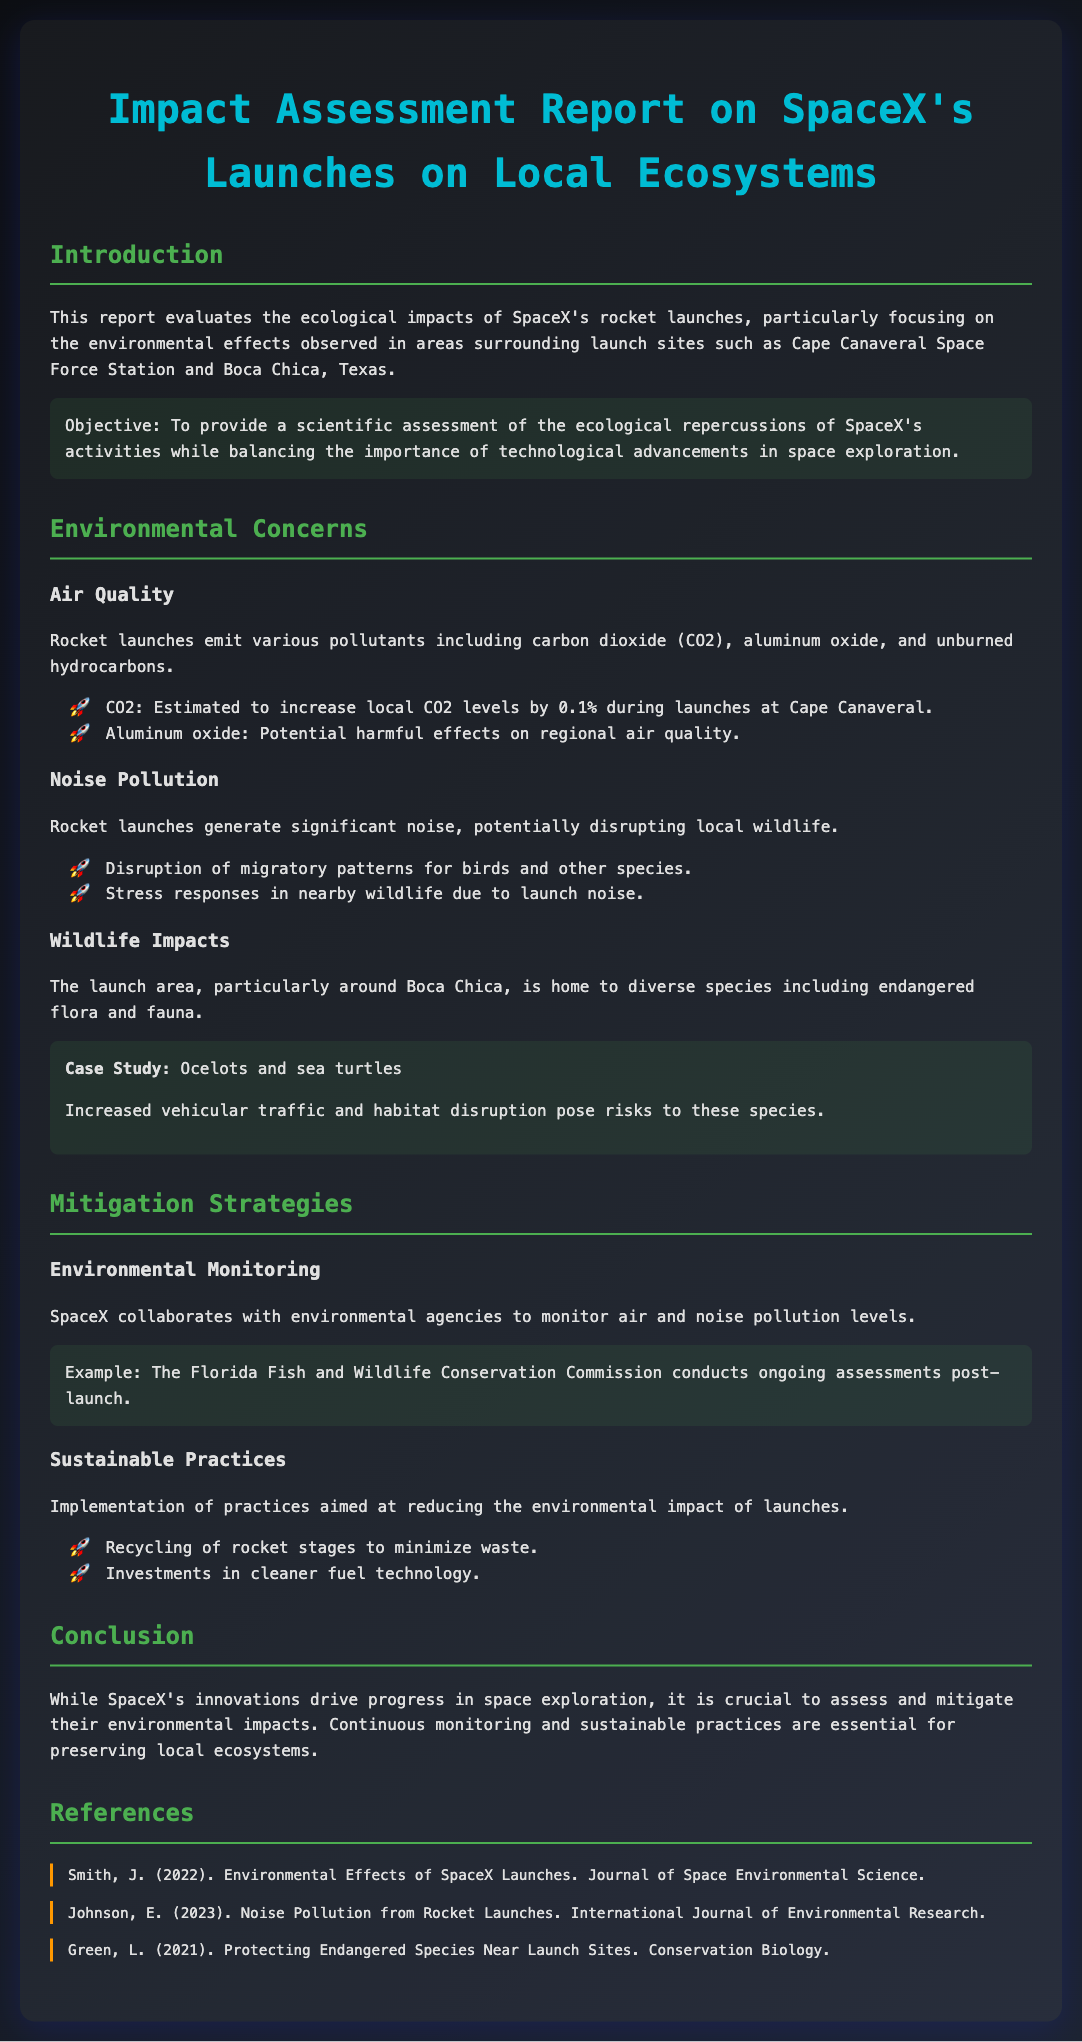What is the main focus of the report? The report evaluates the ecological impacts of SpaceX's rocket launches, particularly on local ecosystems.
Answer: Ecological impacts of SpaceX's rocket launches How much do rocket launches increase local CO2 levels? The document states that CO2 levels are estimated to increase by 0.1% during launches at Cape Canaveral.
Answer: 0.1% Which species are highlighted in the case study? The case study mentions specific species affected by launches in the Boca Chica area.
Answer: Ocelots and sea turtles What is one of the mitigation strategies mentioned? The report lists practices SpaceX is implementing to reduce environmental impact.
Answer: Environmental Monitoring Who conducts ongoing assessments post-launch? The document indicates collaboration with environmental agencies for monitoring air and noise pollution.
Answer: Florida Fish and Wildlife Conservation Commission What type of pollution is generated by rocket launches? The report discusses various forms of pollution emitted during launches.
Answer: Noise What is the conclusion regarding SpaceX's innovations? The document concludes that ongoing assessment and mitigation of environmental impacts are essential.
Answer: Continuous monitoring and sustainable practices are essential What is one example of sustainable practices mentioned in the document? The report outlines efforts towards sustainable practices to lessen environmental impacts.
Answer: Recycling of rocket stages What aspect of local wildlife is negatively affected by noise? The document states that noise pollution disrupts certain behaviors in wildlife.
Answer: Disruption of migratory patterns 